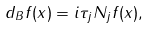Convert formula to latex. <formula><loc_0><loc_0><loc_500><loc_500>d _ { B } f ( x ) = i \tau _ { j } N _ { j } f ( x ) ,</formula> 